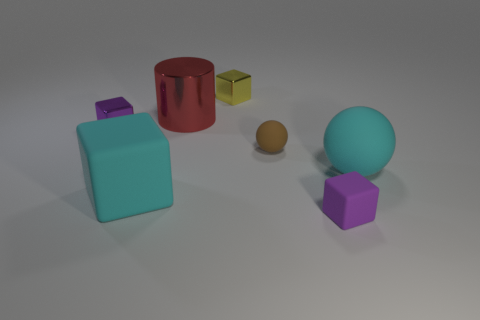What is the color of the shiny object to the right of the red metal object?
Give a very brief answer. Yellow. Is there a thing that is to the left of the purple thing on the left side of the big block?
Make the answer very short. No. What number of things are purple things that are to the right of the large red cylinder or large blocks?
Give a very brief answer. 2. Is there any other thing that has the same size as the brown sphere?
Give a very brief answer. Yes. What material is the small cube that is in front of the big rubber thing in front of the big matte ball?
Offer a terse response. Rubber. Are there an equal number of cyan blocks in front of the purple matte cube and tiny blocks that are in front of the red object?
Make the answer very short. No. How many things are small rubber objects left of the purple rubber cube or blocks to the left of the brown thing?
Make the answer very short. 4. What is the small block that is on the right side of the cylinder and behind the big ball made of?
Offer a terse response. Metal. What is the size of the purple block left of the metallic block that is behind the small purple block that is behind the cyan matte sphere?
Give a very brief answer. Small. Are there more red matte spheres than cubes?
Your answer should be very brief. No. 